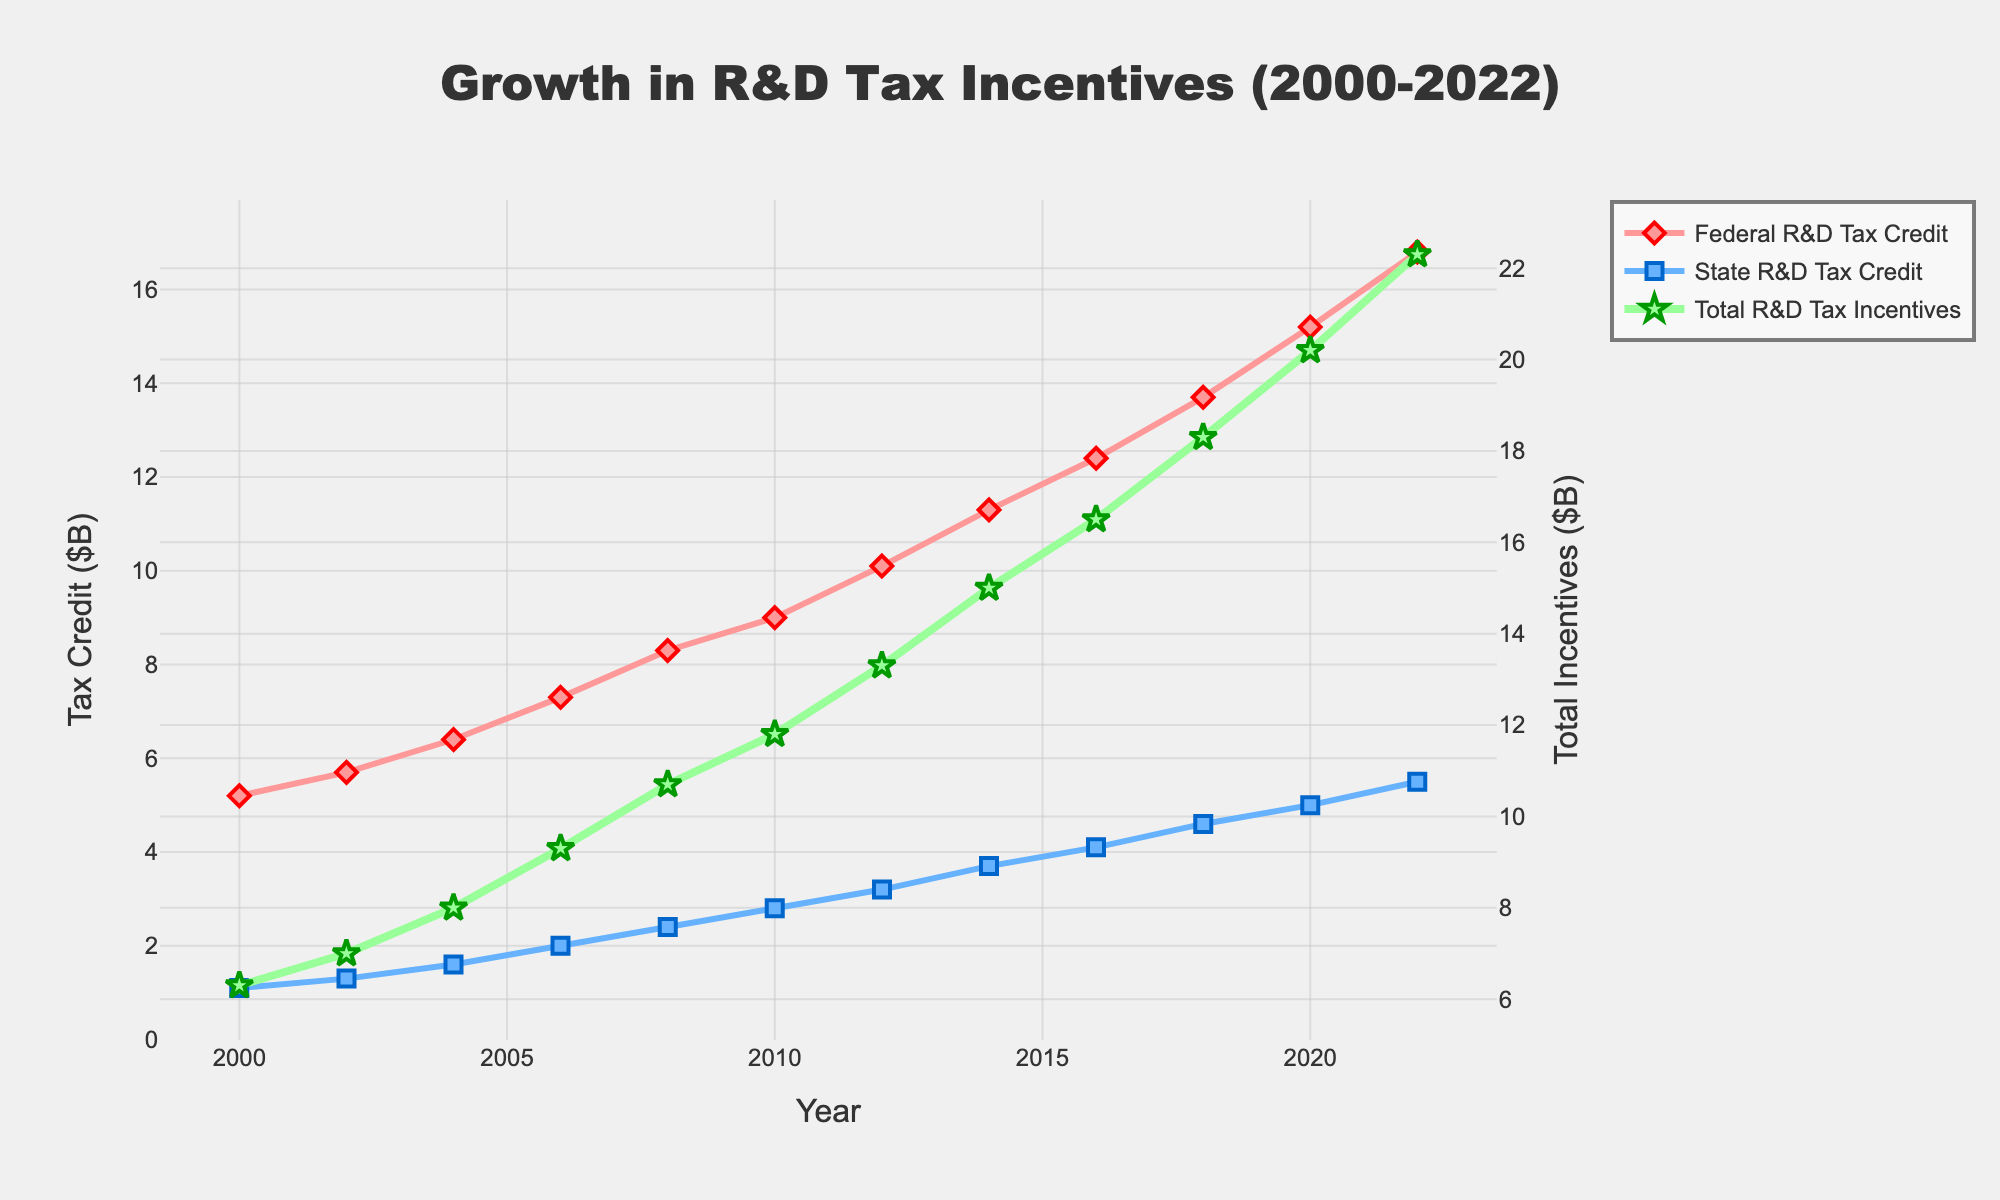What is the overall trend in federal R&D tax credits from 2000 to 2022? Observe the line representing "Federal R&D Tax Credit" and note that it shows a steady increase over the years from 5.2 billion in 2000 to 16.8 billion in 2022.
Answer: A steady increase Which year saw the highest total R&D tax incentives and what was the amount? Look at the data points for "Total R&D Tax Incentives" and find the maximum value, which occurs in 2022 with a value of 22.3 billion.
Answer: 2022, 22.3 billion How does the state R&D tax credit in 2010 compare to the federal R&D tax credit in the same year? Refer to the figure for 2010 and compare the two lines: state R&D tax credit is 2.8 billion, while the federal R&D tax credit is 9.0 billion.
Answer: State: 2.8 billion, Federal: 9.0 billion Calculate the percent increase in total R&D tax incentives from 2000 to 2022. Calculate the percent change: ((22.3 - 6.3) / 6.3) * 100 = approximately 254.0%
Answer: Approximately 254.0% In which year was the gap between federal and state R&D tax credits the smallest? Find the smallest gap by comparing the differences: the smallest gap is observed in 2022, with federal at 16.8 billion and state at 5.5 billion, giving a gap of 11.3 billion.
Answer: 2022 What visual attributes distinguish the line representing "Total R&D Tax Incentives" from the other lines? It is a thicker green line, using stars for markers, and is plotted on the secondary y-axis.
Answer: Thicker green line with stars Which year had an equal amount increase for both federal and state R&D tax credits compared to two years before? Compare bi-yearly increases: from 2020 to 2022, both federal and state tax credits increased by 1.6 billion each (Federal from 15.2 to 16.8, State from 5.0 to 5.5).
Answer: 2022 What is the difference in total R&D tax incentives between 2008 and 2012? Subtract the value of 2008 from 2012: 13.3 billion - 10.7 billion = 2.6 billion.
Answer: 2.6 billion What color is the line that shows state R&D tax credits? Identify the color of the state R&D tax credit line, which is blue.
Answer: Blue How does the average annual increase in federal R&D tax credits compare to the average annual increase in total R&D tax incentives? Calculate average annual increase for both: 
Federal: (16.8-5.2) / 22 ≈ 0.527 billion/year, 
Total: (22.3-6.3) / 22 ≈ 0.727 billion/year. 
Total R&D increases faster on average than Federal R&D.
Answer: Federal: ~0.527 billion/year, Total: ~0.727 billion/year 